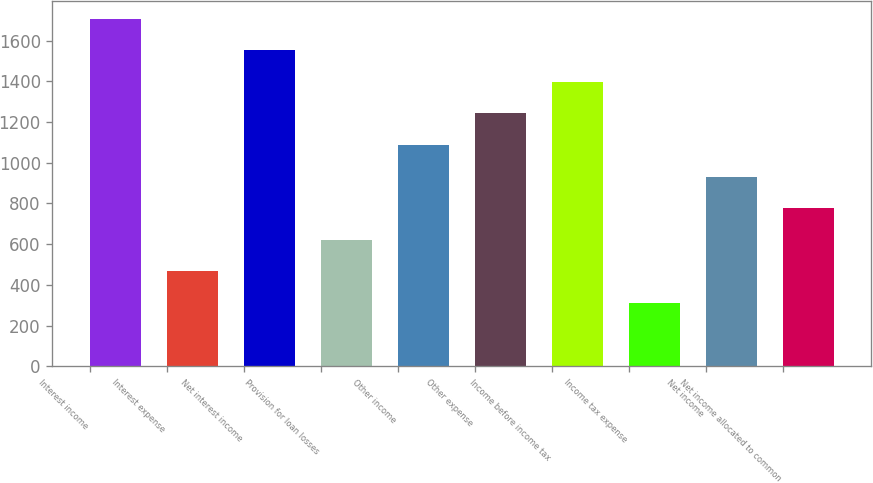Convert chart to OTSL. <chart><loc_0><loc_0><loc_500><loc_500><bar_chart><fcel>Interest income<fcel>Interest expense<fcel>Net interest income<fcel>Provision for loan losses<fcel>Other income<fcel>Other expense<fcel>Income before income tax<fcel>Income tax expense<fcel>Net income<fcel>Net income allocated to common<nl><fcel>1708.26<fcel>466.5<fcel>1553.04<fcel>621.72<fcel>1087.38<fcel>1242.6<fcel>1397.82<fcel>311.28<fcel>932.16<fcel>776.94<nl></chart> 